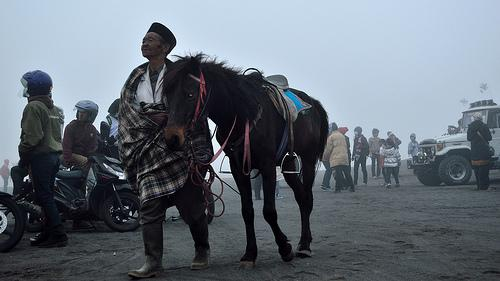Based on the image, what emotions and feelings do you think the people might be experiencing? The people in the image might be experiencing a sense of adventure, camaraderie, and enjoyment of the outdoors. What color is the horse and what accessory is placed on it? The horse is dark brown with a leather saddle on it. Provide a brief description of the scene depicted in the image. The image shows a man walking with a horse on a sandy beach, people wearing helmets and jackets, a parked white truck and a motorcycle, and various objects like saddles, hats, and boots. What are the people in the image wearing on their heads? People in the image are wearing helmets, hats, and protective headgear. Mention the type of day and the landscape shown in the image. The image portrays a misty day on a sandy beach. Identify the types of vehicles and their colors found in the image. The image has a parked white truck and a parked white jeep. Describe any noticeable interactions between the objects or people in the image. A man is leading a horse using a rope, people are conversing in a group, and a motorcycle rider is sitting on his bike. State the number of people and the animals present in the image. There are several people and at least one horse in the image. Describe the main activity that the man is performing with the horse. A man is walking a dark brown horse on the sand. 